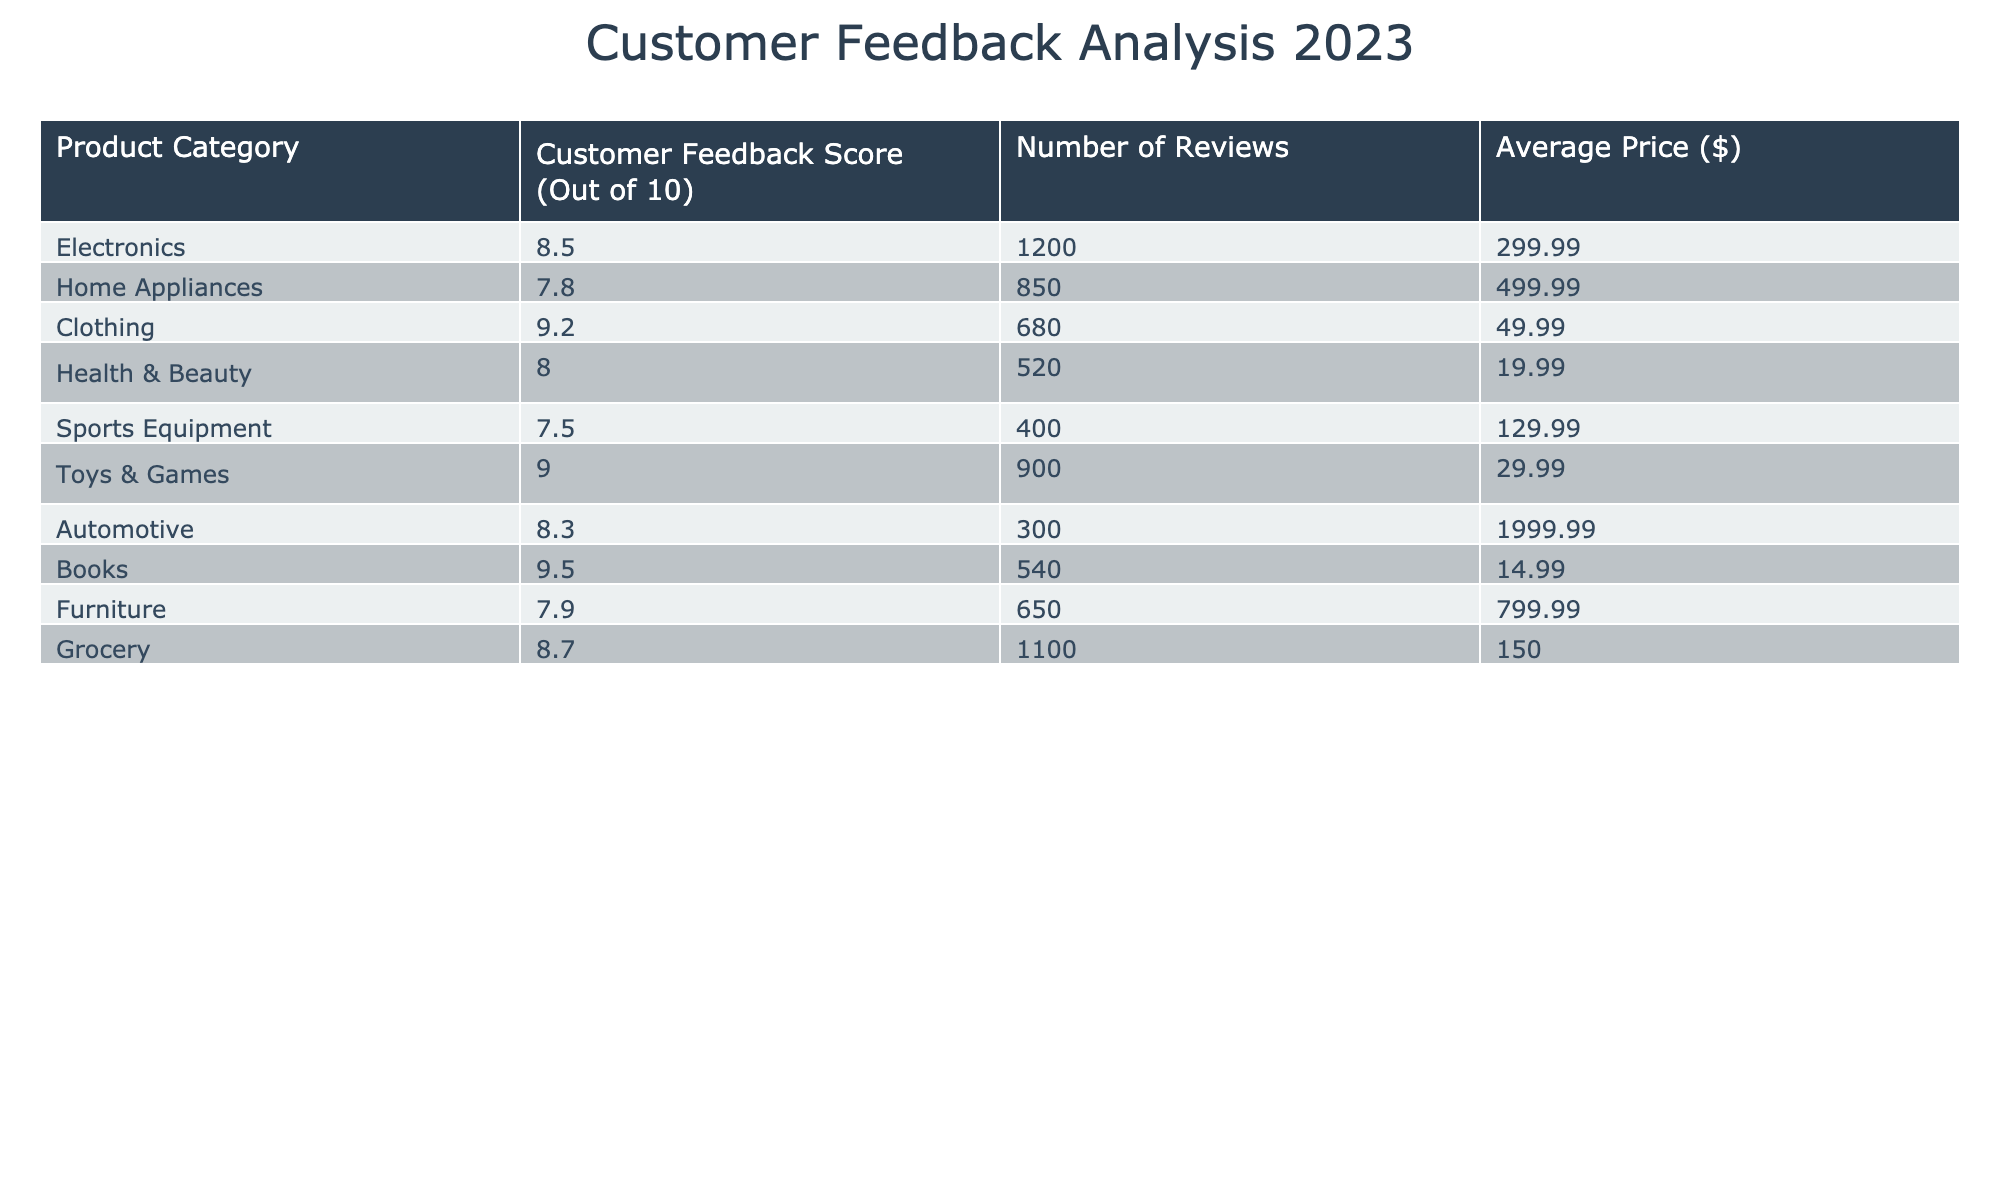What is the product category with the highest customer feedback score? The table shows customer feedback scores for various product categories. By reviewing the scores listed, we can see that "Books" has the highest score of 9.5.
Answer: Books How many reviews did the "Clothing" category receive? The table indicates that the "Clothing" category received 680 reviews.
Answer: 680 What is the average feedback score of "Home Appliances" and "Sports Equipment"? To find the average score, we first take the scores of "Home Appliances" (7.8) and "Sports Equipment" (7.5). Adding these gives us 15.3. Dividing by 2 (the number of categories) gives an average score of 15.3 / 2 = 7.65.
Answer: 7.65 Is the customer feedback score for "Electronics" greater than or equal to 8? The customer feedback score for "Electronics" is 8.5, which is greater than 8, confirming the statement is true.
Answer: Yes Which product category has the lowest customer feedback score? Upon examining the scores in the table, "Sports Equipment" has the lowest score at 7.5.
Answer: Sports Equipment What is the total number of reviews across all product categories? To get the total number of reviews, we will sum the number of reviews for each category: 1200 + 850 + 680 + 520 + 400 + 900 + 300 + 540 + 650 + 1100 = 6190.
Answer: 6190 Do "Toys & Games" have a feedback score higher than 8? The feedback score for "Toys & Games" is 9.0, which is indeed higher than 8, making the statement true.
Answer: Yes What is the difference in customer feedback scores between "Health & Beauty" and "Automotive"? We look at the scores: "Health & Beauty" has a score of 8.0 and "Automotive" has a score of 8.3. The difference is 8.3 - 8.0 = 0.3.
Answer: 0.3 Which product category has the highest price and what is that price? In the table, "Automotive" has the highest price listed at $1999.99.
Answer: $1999.99 What percentage of the total number of reviews does "Grocery" represent? First, we know the total number of reviews is 6190. The "Grocery" category has 1100 reviews. To find the percentage, we calculate (1100 / 6190) * 100, which is approximately 17.78%.
Answer: 17.78% 